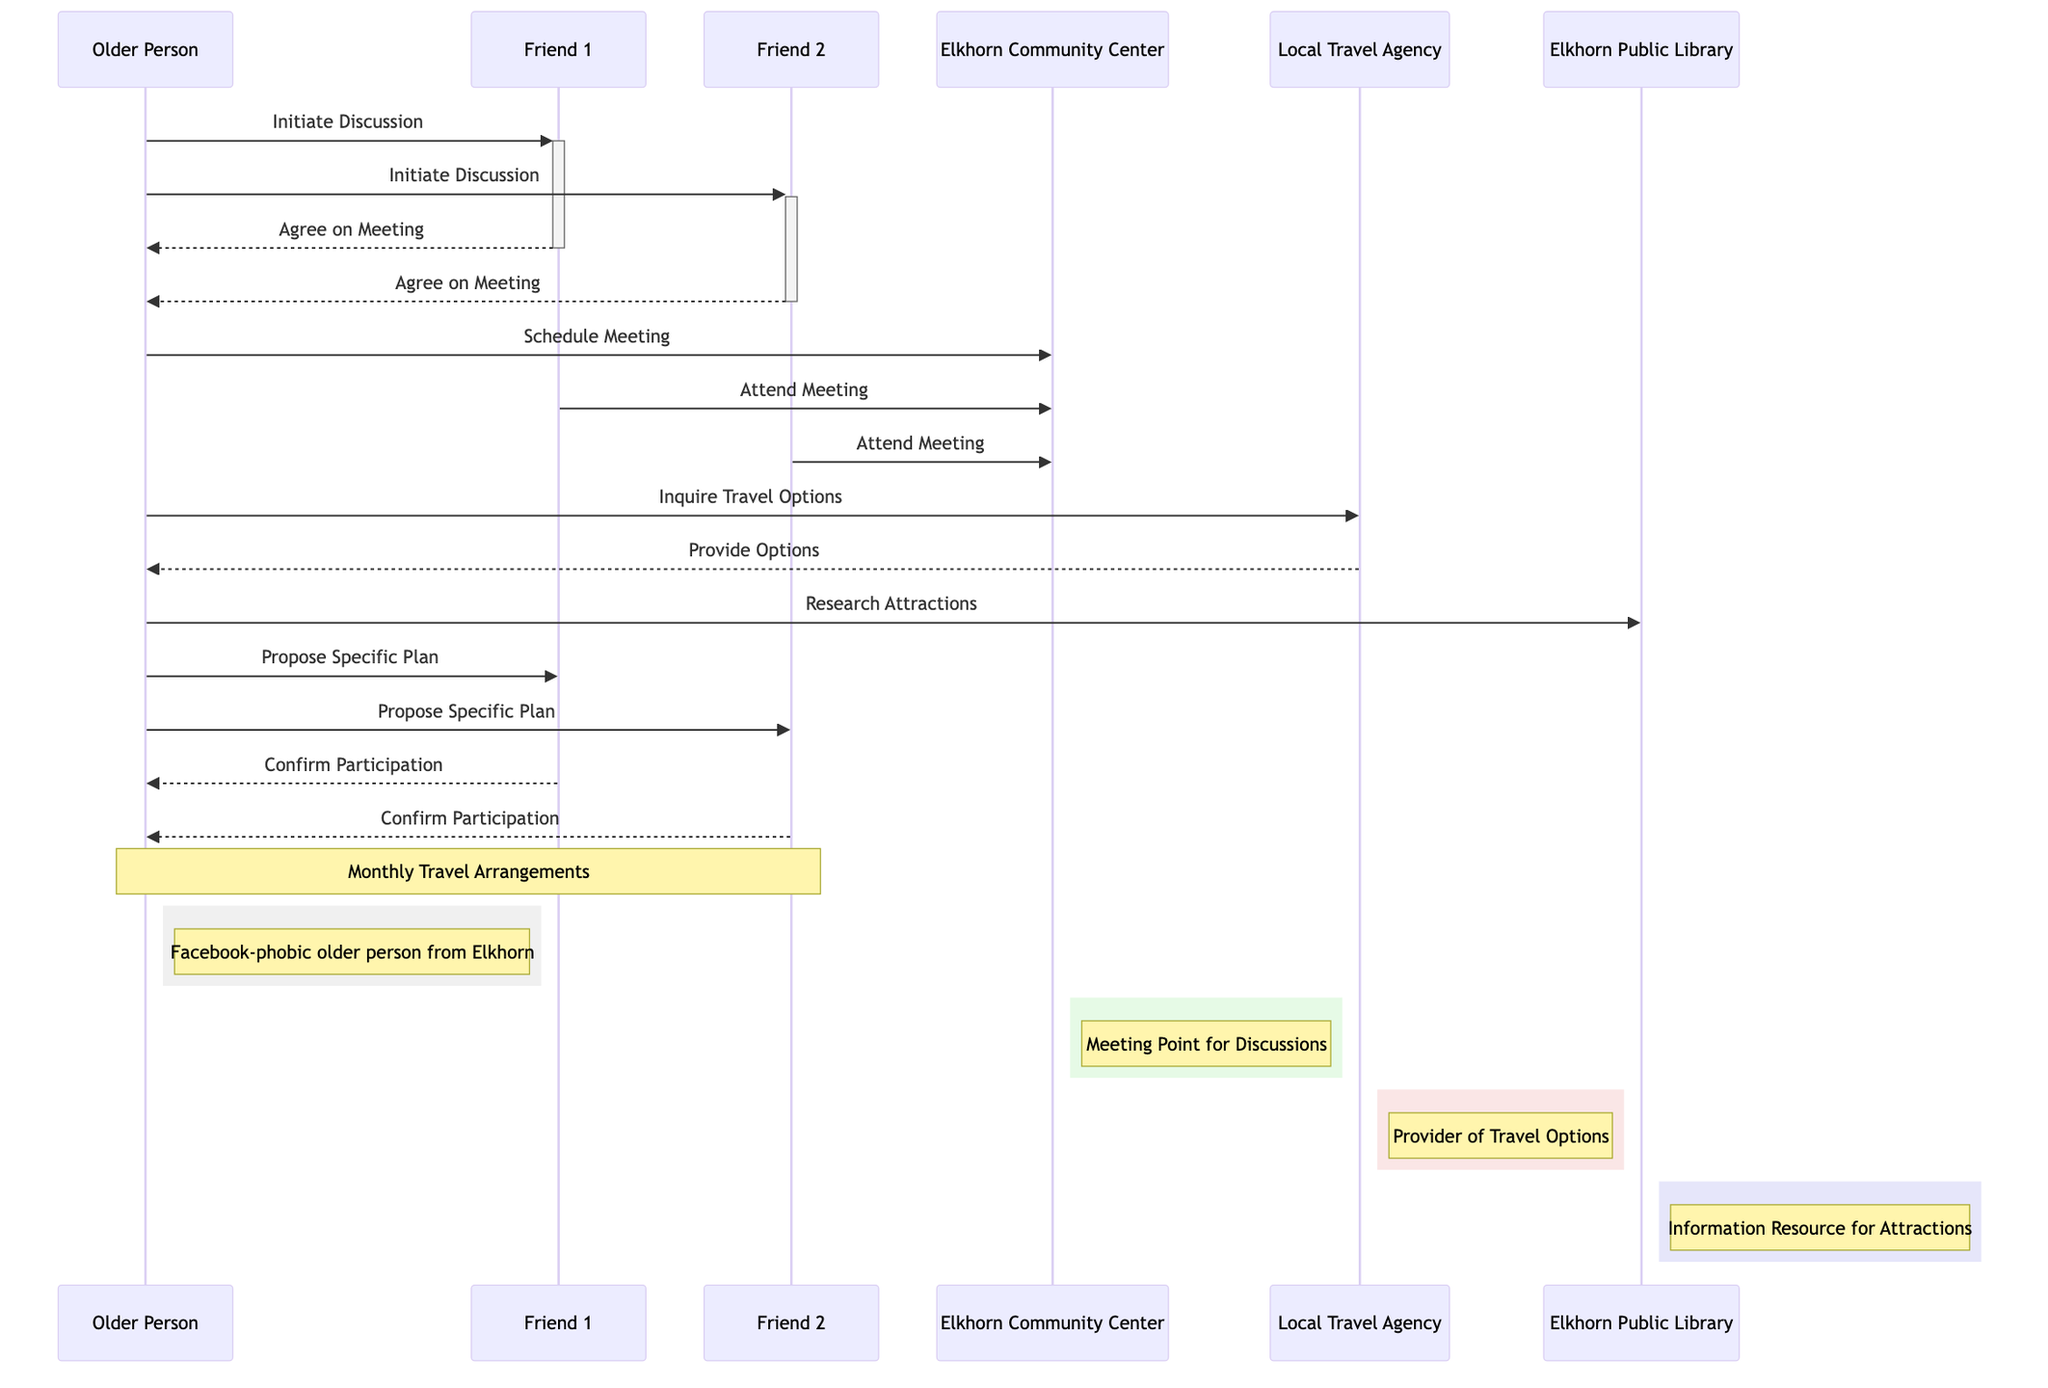What's the role of the Older Person in this diagram? The Older Person is identified as the "Initiator of Travel Arrangements," which means they are the one who begins the process of planning the monthly travel with their friends. This is confirmed by the sequence where the Older Person initiates discussions with the friends.
Answer: Initiator of Travel Arrangements What is the destination for the monthly trip? The "Nearby Attraction" is noted as the destination for the monthly travel plan. Although it doesn't specify a name, it indicates that the group aims to visit such attractions each month as part of their plan.
Answer: Nearby Attraction How many participants are involved in the monthly travel arrangement? There are three people involved in the arrangement: the Older Person, Friend 1, and Friend 2. Each of them has specific roles throughout the travel planning process.
Answer: Three What type of communication tool does the Older Person use to confirm participation from friends? Friends confirm their participation using either a phone call or an email. The diagram specifically labels these forms of communication as confirmation methods.
Answer: Phone Call or Email What action does the Older Person take after researching attractions? The Older Person proposes a specific travel plan to Friend 1 and Friend 2 after gathering the necessary information about nearby attractions. This is a critical step in the sequence of events.
Answer: Propose Specific Plan How does the Older Person receive travel options? The Older Person contacts the Local Travel Agency to inquire about available travel options, and in return, the agency provides several options. This exchange indicates a flow of information crucial for planning.
Answer: Provide Options What is the role of the Elkhorn Public Library in this sequence? The Elkhorn Public Library is labeled as an "Information Resource for Attractions," and it is where the Older Person goes to gather information regarding the nearby attractions for their proposed travel.
Answer: Information Resource for Attractions What is the meeting point where the discussion takes place? The Elkhorn Community Center serves as the meeting point for discussions regarding the travel arrangements, established early in the communication between the Older Person and the friends.
Answer: Elkhorn Community Center How do the friends agree to meet? Friends agree to meet by responding positively to the Older Person's call for a discussion about the travel arrangements. This agreement is communicated back to the Older Person as a clear confirmation.
Answer: Agree on Meeting 